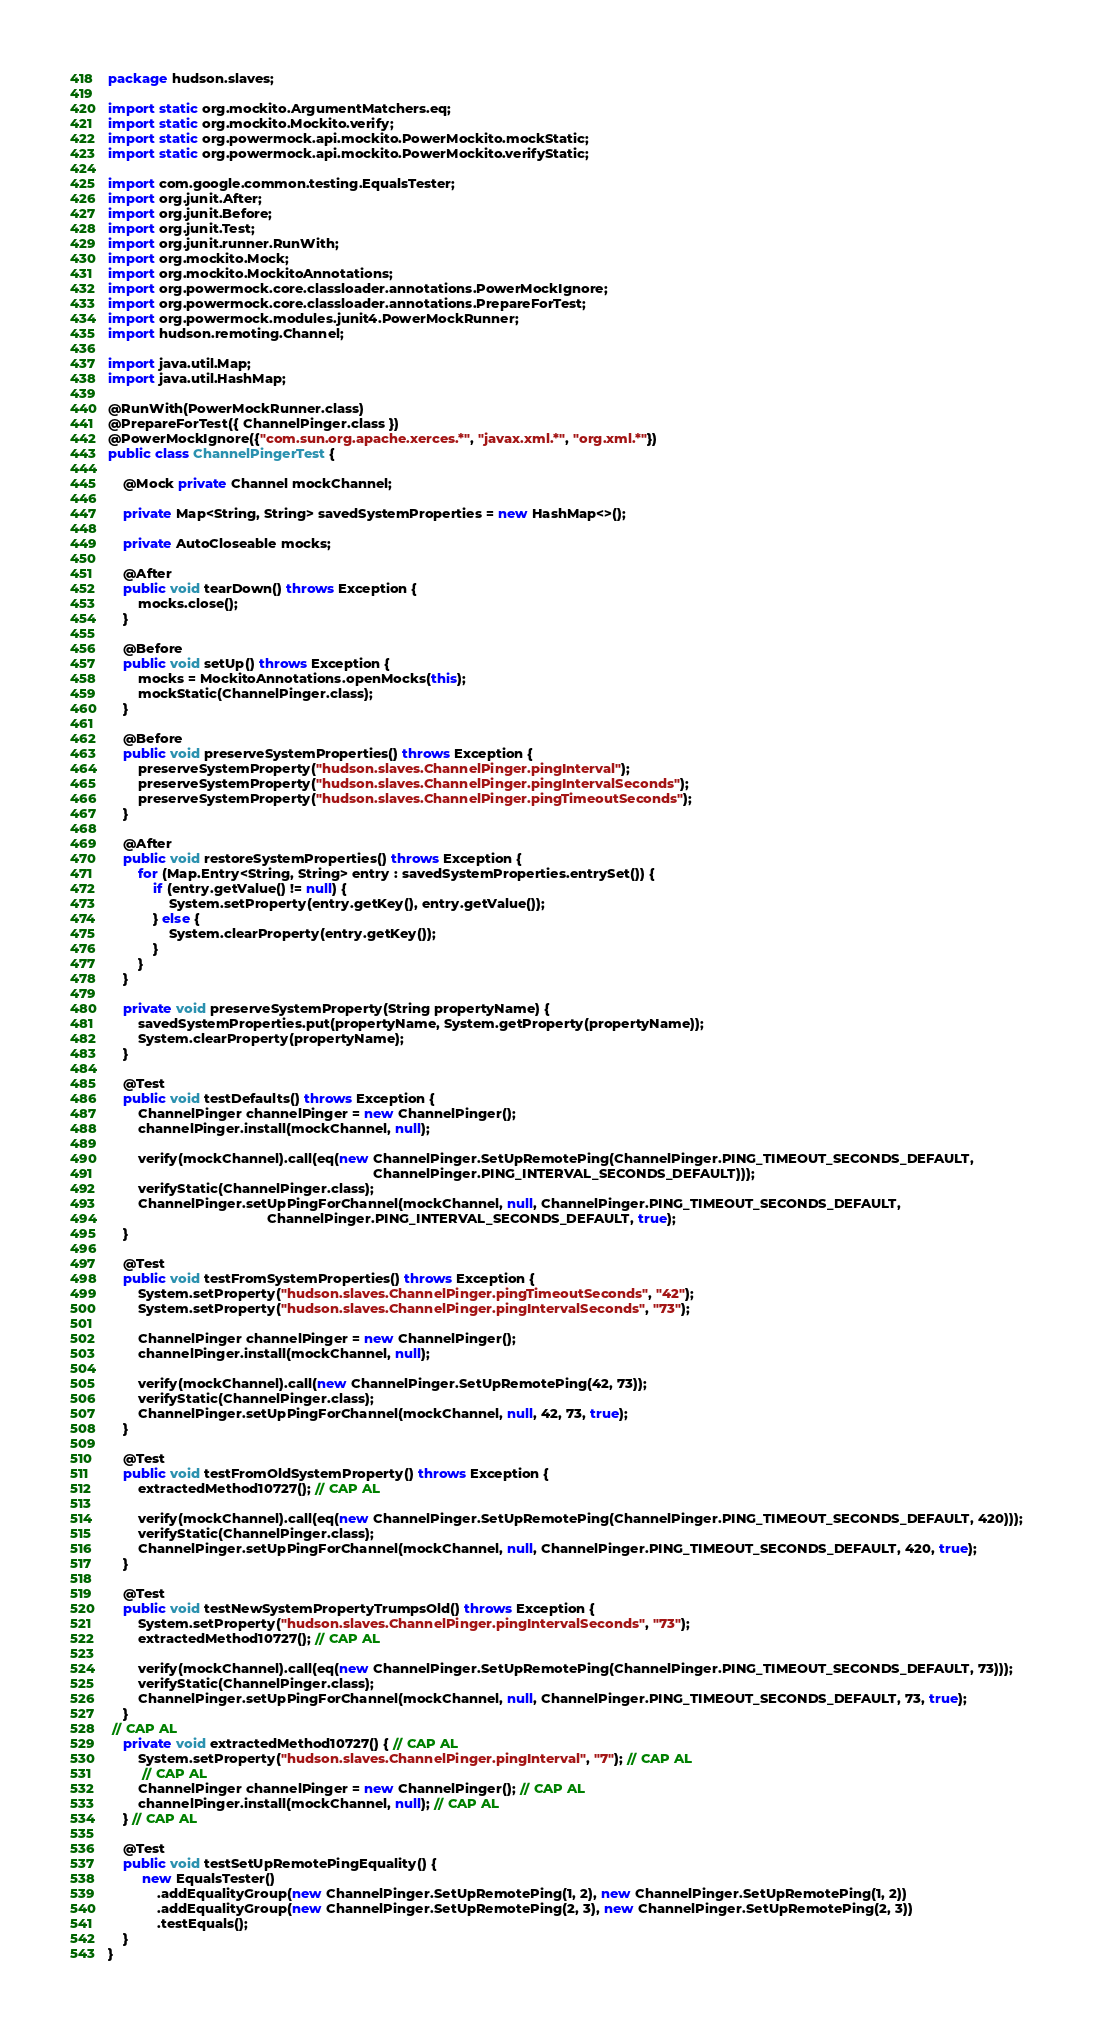<code> <loc_0><loc_0><loc_500><loc_500><_Java_>package hudson.slaves;

import static org.mockito.ArgumentMatchers.eq;
import static org.mockito.Mockito.verify;
import static org.powermock.api.mockito.PowerMockito.mockStatic;
import static org.powermock.api.mockito.PowerMockito.verifyStatic;

import com.google.common.testing.EqualsTester;
import org.junit.After;
import org.junit.Before;
import org.junit.Test;
import org.junit.runner.RunWith;
import org.mockito.Mock;
import org.mockito.MockitoAnnotations;
import org.powermock.core.classloader.annotations.PowerMockIgnore;
import org.powermock.core.classloader.annotations.PrepareForTest;
import org.powermock.modules.junit4.PowerMockRunner;
import hudson.remoting.Channel;

import java.util.Map;
import java.util.HashMap;

@RunWith(PowerMockRunner.class)
@PrepareForTest({ ChannelPinger.class })
@PowerMockIgnore({"com.sun.org.apache.xerces.*", "javax.xml.*", "org.xml.*"})
public class ChannelPingerTest {

    @Mock private Channel mockChannel;

    private Map<String, String> savedSystemProperties = new HashMap<>();

    private AutoCloseable mocks;

    @After
    public void tearDown() throws Exception {
        mocks.close();
    }

    @Before
    public void setUp() throws Exception {
        mocks = MockitoAnnotations.openMocks(this);
        mockStatic(ChannelPinger.class);
    }

    @Before
    public void preserveSystemProperties() throws Exception {
        preserveSystemProperty("hudson.slaves.ChannelPinger.pingInterval");
        preserveSystemProperty("hudson.slaves.ChannelPinger.pingIntervalSeconds");
        preserveSystemProperty("hudson.slaves.ChannelPinger.pingTimeoutSeconds");
    }

    @After
    public void restoreSystemProperties() throws Exception {
        for (Map.Entry<String, String> entry : savedSystemProperties.entrySet()) {
            if (entry.getValue() != null) {
                System.setProperty(entry.getKey(), entry.getValue());
            } else {
                System.clearProperty(entry.getKey());
            }
        }
    }

    private void preserveSystemProperty(String propertyName) {
        savedSystemProperties.put(propertyName, System.getProperty(propertyName));
        System.clearProperty(propertyName);
    }

    @Test
    public void testDefaults() throws Exception {
        ChannelPinger channelPinger = new ChannelPinger();
        channelPinger.install(mockChannel, null);

        verify(mockChannel).call(eq(new ChannelPinger.SetUpRemotePing(ChannelPinger.PING_TIMEOUT_SECONDS_DEFAULT,
                                                                      ChannelPinger.PING_INTERVAL_SECONDS_DEFAULT)));
        verifyStatic(ChannelPinger.class);
        ChannelPinger.setUpPingForChannel(mockChannel, null, ChannelPinger.PING_TIMEOUT_SECONDS_DEFAULT,
                                          ChannelPinger.PING_INTERVAL_SECONDS_DEFAULT, true);
    }

    @Test
    public void testFromSystemProperties() throws Exception {
        System.setProperty("hudson.slaves.ChannelPinger.pingTimeoutSeconds", "42");
        System.setProperty("hudson.slaves.ChannelPinger.pingIntervalSeconds", "73");

        ChannelPinger channelPinger = new ChannelPinger();
        channelPinger.install(mockChannel, null);

        verify(mockChannel).call(new ChannelPinger.SetUpRemotePing(42, 73));
        verifyStatic(ChannelPinger.class);
        ChannelPinger.setUpPingForChannel(mockChannel, null, 42, 73, true);
    }

    @Test
    public void testFromOldSystemProperty() throws Exception {
        extractedMethod10727(); // CAP AL

        verify(mockChannel).call(eq(new ChannelPinger.SetUpRemotePing(ChannelPinger.PING_TIMEOUT_SECONDS_DEFAULT, 420)));
        verifyStatic(ChannelPinger.class);
        ChannelPinger.setUpPingForChannel(mockChannel, null, ChannelPinger.PING_TIMEOUT_SECONDS_DEFAULT, 420, true);
    }

    @Test
    public void testNewSystemPropertyTrumpsOld() throws Exception {
        System.setProperty("hudson.slaves.ChannelPinger.pingIntervalSeconds", "73");
        extractedMethod10727(); // CAP AL

        verify(mockChannel).call(eq(new ChannelPinger.SetUpRemotePing(ChannelPinger.PING_TIMEOUT_SECONDS_DEFAULT, 73)));
        verifyStatic(ChannelPinger.class);
        ChannelPinger.setUpPingForChannel(mockChannel, null, ChannelPinger.PING_TIMEOUT_SECONDS_DEFAULT, 73, true);
    }
 // CAP AL
    private void extractedMethod10727() { // CAP AL
        System.setProperty("hudson.slaves.ChannelPinger.pingInterval", "7"); // CAP AL
         // CAP AL
        ChannelPinger channelPinger = new ChannelPinger(); // CAP AL
        channelPinger.install(mockChannel, null); // CAP AL
    } // CAP AL

    @Test
    public void testSetUpRemotePingEquality() {
         new EqualsTester()
             .addEqualityGroup(new ChannelPinger.SetUpRemotePing(1, 2), new ChannelPinger.SetUpRemotePing(1, 2))
             .addEqualityGroup(new ChannelPinger.SetUpRemotePing(2, 3), new ChannelPinger.SetUpRemotePing(2, 3))
             .testEquals();
    }
}
</code> 